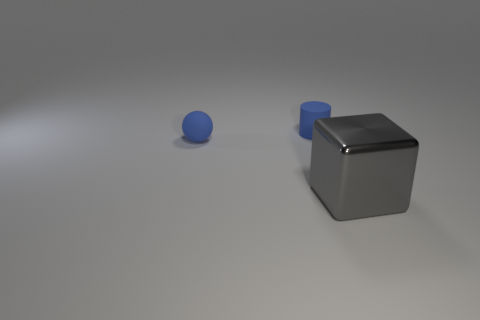Is there any other thing that has the same material as the tiny blue sphere?
Offer a terse response. Yes. There is a tiny rubber object behind the matte ball; is its color the same as the tiny object that is on the left side of the blue cylinder?
Your response must be concise. Yes. There is a blue object that is left of the blue rubber thing on the right side of the tiny blue object in front of the tiny blue cylinder; what is its material?
Ensure brevity in your answer.  Rubber. Is the number of small cyan rubber balls greater than the number of blue objects?
Your answer should be very brief. No. Is there any other thing of the same color as the rubber sphere?
Provide a succinct answer. Yes. There is a blue object that is made of the same material as the small cylinder; what size is it?
Give a very brief answer. Small. What material is the big gray block?
Keep it short and to the point. Metal. What number of blue matte cylinders have the same size as the blue matte sphere?
Offer a terse response. 1. What is the shape of the object that is the same color as the cylinder?
Make the answer very short. Sphere. Is there another shiny thing of the same shape as the gray object?
Your answer should be compact. No. 